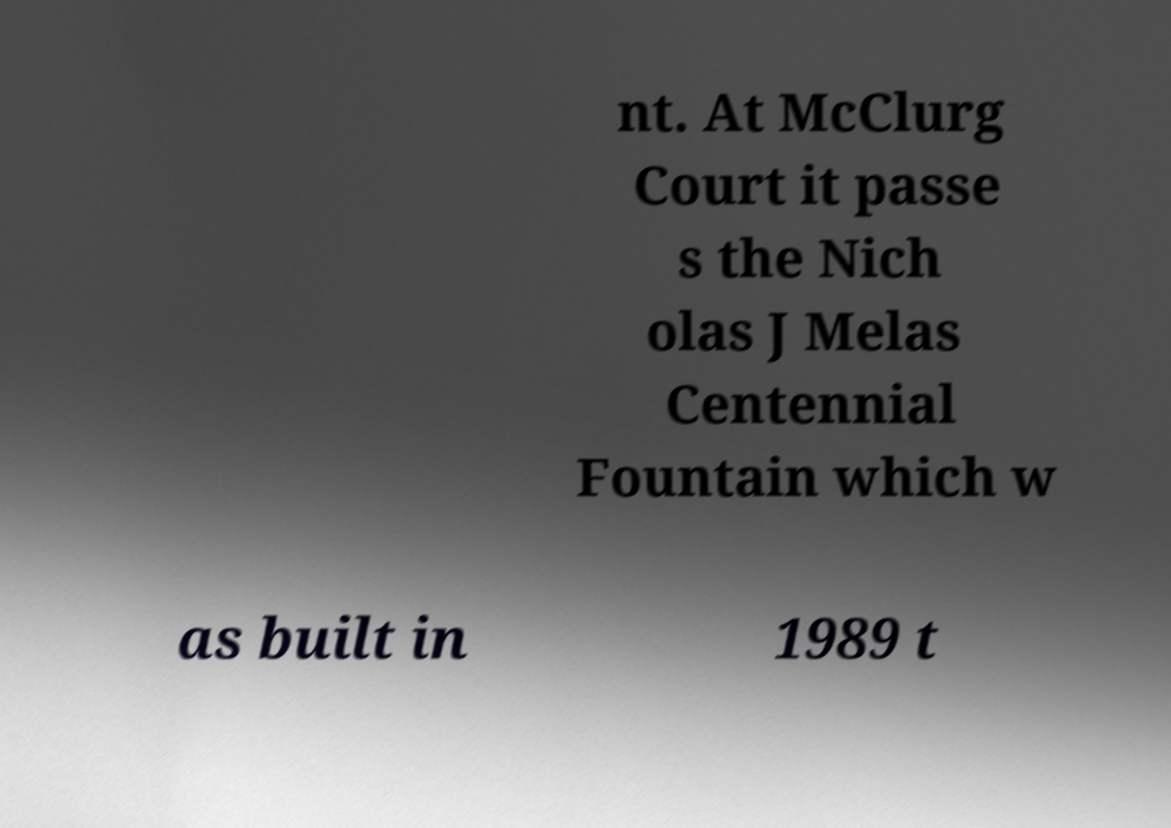There's text embedded in this image that I need extracted. Can you transcribe it verbatim? nt. At McClurg Court it passe s the Nich olas J Melas Centennial Fountain which w as built in 1989 t 